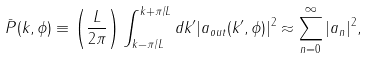<formula> <loc_0><loc_0><loc_500><loc_500>\bar { P } ( k , \phi ) \equiv \left ( \frac { L } { 2 \pi } \right ) \int _ { k - \pi / L } ^ { k + \pi / L } d k ^ { \prime } | a _ { o u t } ( k ^ { \prime } , \phi ) | ^ { 2 } \approx \sum _ { n = 0 } ^ { \infty } | a _ { n } | ^ { 2 } ,</formula> 